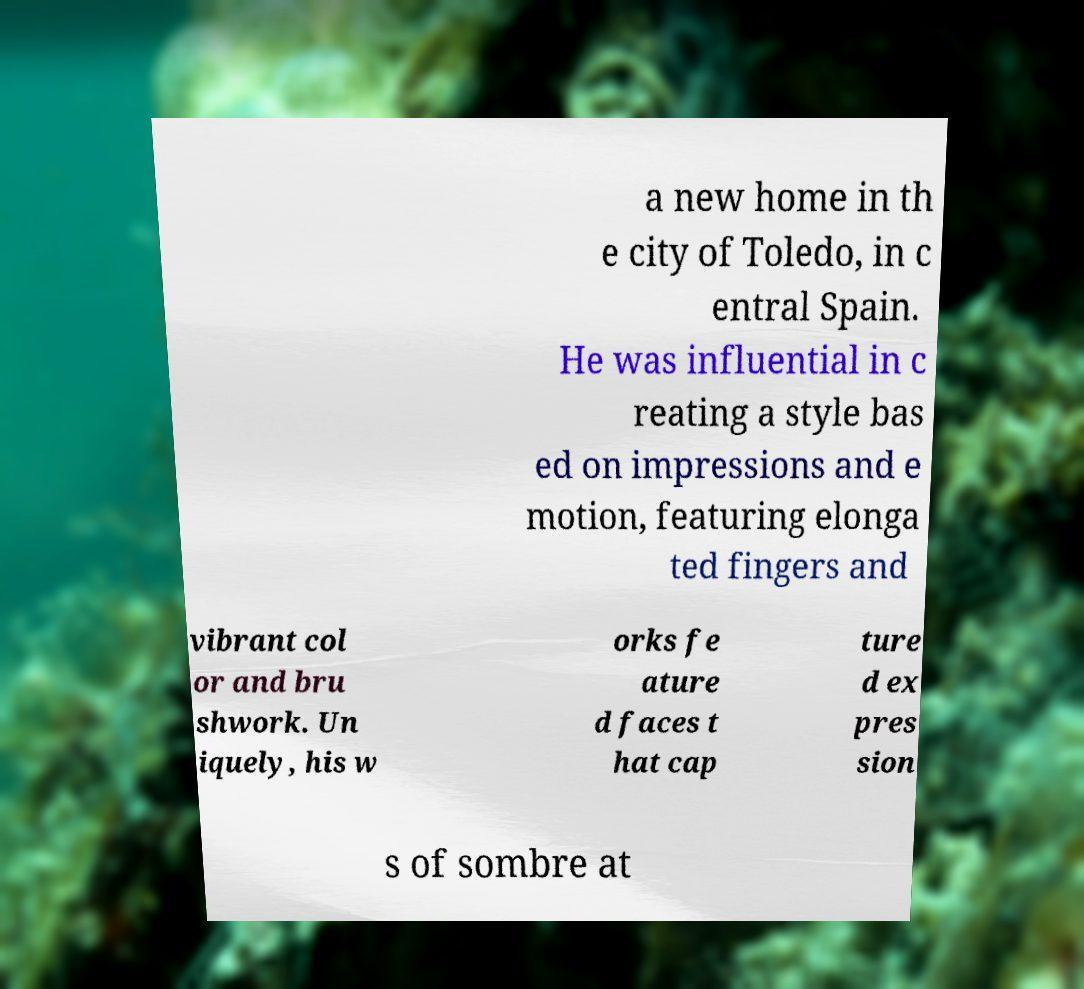Please read and relay the text visible in this image. What does it say? a new home in th e city of Toledo, in c entral Spain. He was influential in c reating a style bas ed on impressions and e motion, featuring elonga ted fingers and vibrant col or and bru shwork. Un iquely, his w orks fe ature d faces t hat cap ture d ex pres sion s of sombre at 